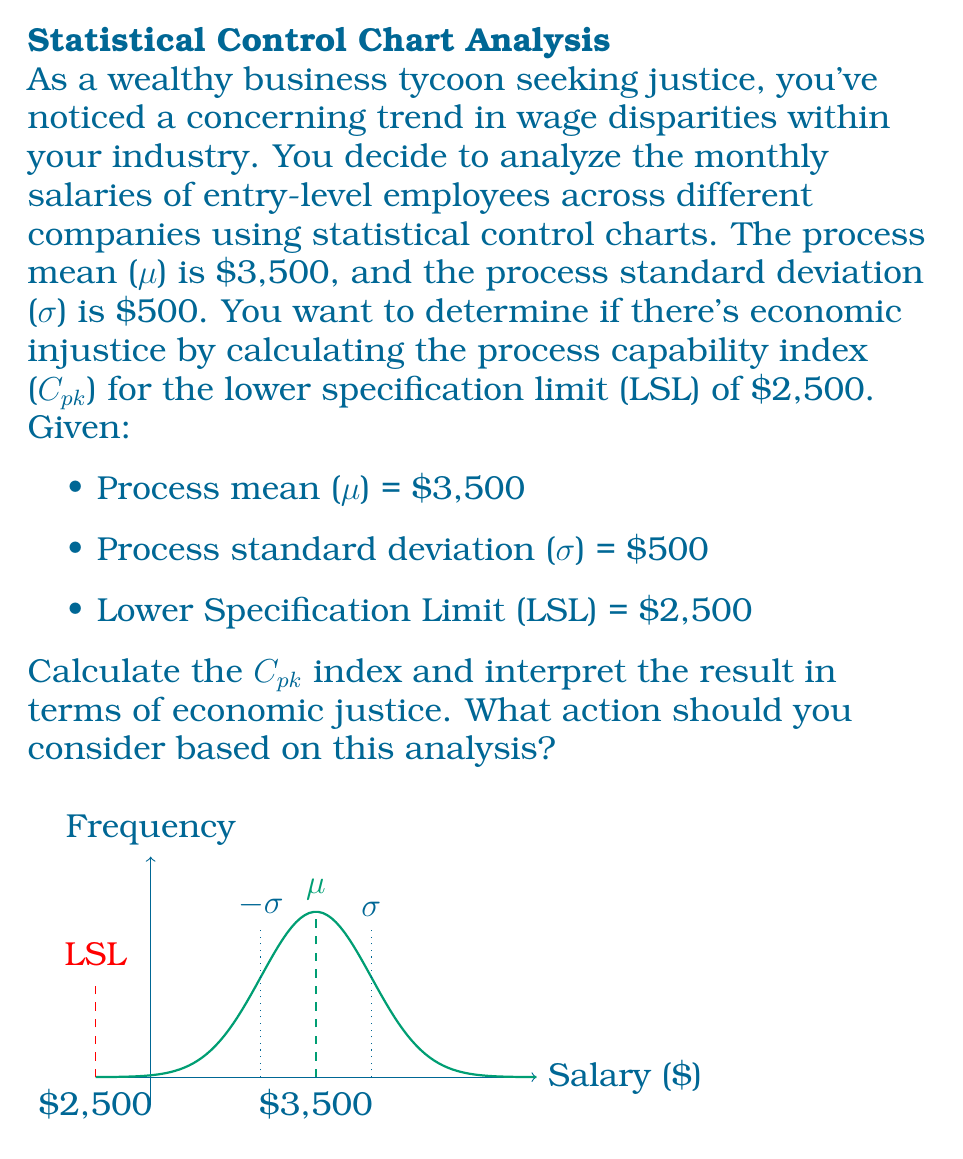Solve this math problem. To analyze economic injustice using the process capability index (Cpk), we'll follow these steps:

1) The Cpk index for the lower specification limit is calculated using the formula:

   $$C_{pk} = \frac{\mu - LSL}{3\sigma}$$

2) Substituting the given values:
   $$C_{pk} = \frac{3500 - 2500}{3 \cdot 500}$$

3) Simplify:
   $$C_{pk} = \frac{1000}{1500} = \frac{2}{3} \approx 0.67$$

4) Interpretation of Cpk:
   - Cpk < 1.0: The process is not capable
   - 1.0 ≤ Cpk < 1.33: The process is marginally capable
   - Cpk ≥ 1.33: The process is capable

5) With Cpk ≈ 0.67 < 1.0, the process is not capable. This indicates significant economic injustice in the industry's entry-level salaries.

6) The low Cpk value suggests that a considerable portion of entry-level employees may be receiving salaries below the lower specification limit of $2,500, which is unacceptable.

7) Action to consider: As a wealthy business tycoon seeking justice, you should advocate for industry-wide salary reforms. This could include:
   - Raising the minimum entry-level salary
   - Implementing standardized pay scales
   - Encouraging transparency in compensation practices
   - Investing in employee training and development to justify higher wages
   - Using your influence to push for regulatory changes that ensure fair compensation
Answer: Cpk ≈ 0.67, indicating significant economic injustice. Action: Advocate for industry-wide salary reforms. 